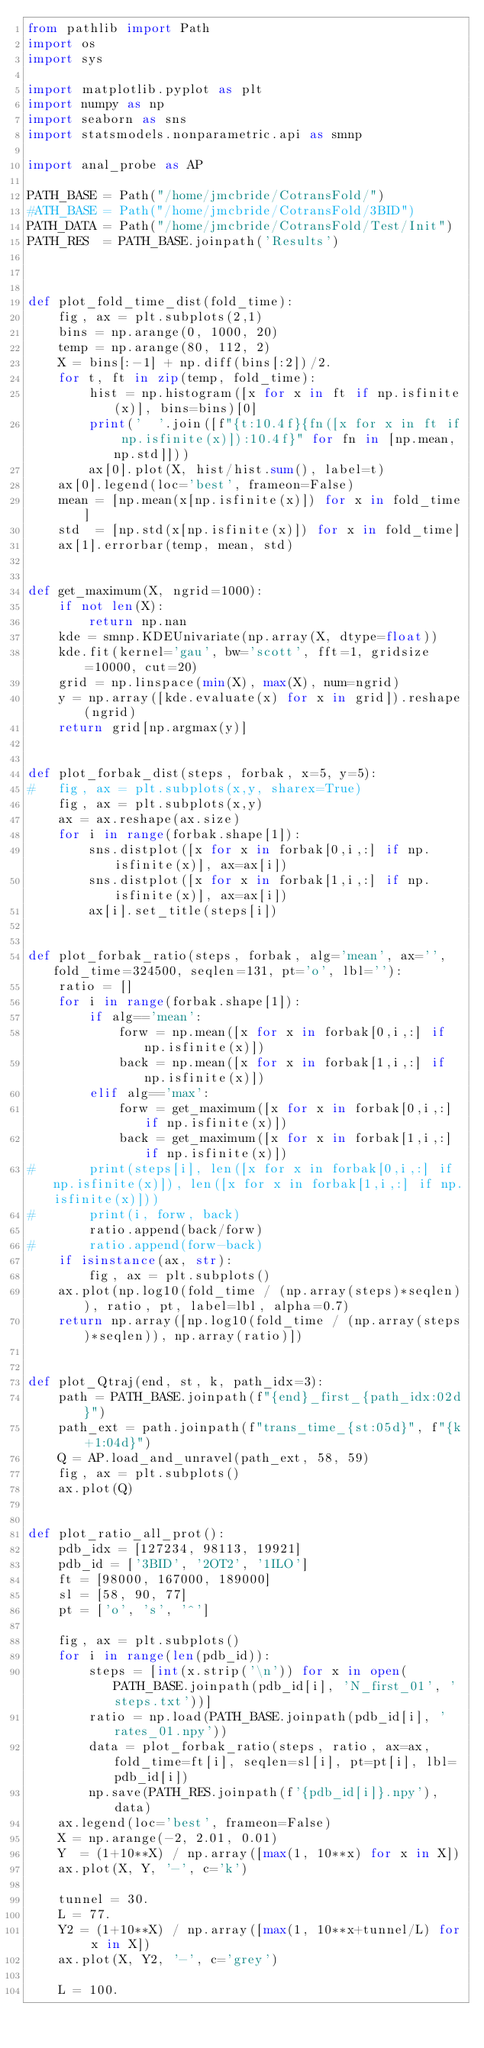Convert code to text. <code><loc_0><loc_0><loc_500><loc_500><_Python_>from pathlib import Path
import os
import sys

import matplotlib.pyplot as plt
import numpy as np
import seaborn as sns
import statsmodels.nonparametric.api as smnp 

import anal_probe as AP

PATH_BASE = Path("/home/jmcbride/CotransFold/")
#ATH_BASE = Path("/home/jmcbride/CotransFold/3BID")
PATH_DATA = Path("/home/jmcbride/CotransFold/Test/Init")
PATH_RES  = PATH_BASE.joinpath('Results')



def plot_fold_time_dist(fold_time):
    fig, ax = plt.subplots(2,1)
    bins = np.arange(0, 1000, 20)
    temp = np.arange(80, 112, 2)
    X = bins[:-1] + np.diff(bins[:2])/2.
    for t, ft in zip(temp, fold_time):
        hist = np.histogram([x for x in ft if np.isfinite(x)], bins=bins)[0]
        print('  '.join([f"{t:10.4f}{fn([x for x in ft if np.isfinite(x)]):10.4f}" for fn in [np.mean, np.std]]))
        ax[0].plot(X, hist/hist.sum(), label=t)
    ax[0].legend(loc='best', frameon=False)
    mean = [np.mean(x[np.isfinite(x)]) for x in fold_time]
    std  = [np.std(x[np.isfinite(x)]) for x in fold_time]
    ax[1].errorbar(temp, mean, std)


def get_maximum(X, ngrid=1000):
    if not len(X):
        return np.nan
    kde = smnp.KDEUnivariate(np.array(X, dtype=float))
    kde.fit(kernel='gau', bw='scott', fft=1, gridsize=10000, cut=20)
    grid = np.linspace(min(X), max(X), num=ngrid)
    y = np.array([kde.evaluate(x) for x in grid]).reshape(ngrid)
    return grid[np.argmax(y)]


def plot_forbak_dist(steps, forbak, x=5, y=5):
#   fig, ax = plt.subplots(x,y, sharex=True)
    fig, ax = plt.subplots(x,y)
    ax = ax.reshape(ax.size)
    for i in range(forbak.shape[1]):
        sns.distplot([x for x in forbak[0,i,:] if np.isfinite(x)], ax=ax[i])
        sns.distplot([x for x in forbak[1,i,:] if np.isfinite(x)], ax=ax[i])
        ax[i].set_title(steps[i])


def plot_forbak_ratio(steps, forbak, alg='mean', ax='', fold_time=324500, seqlen=131, pt='o', lbl=''):
    ratio = []
    for i in range(forbak.shape[1]):
        if alg=='mean':
            forw = np.mean([x for x in forbak[0,i,:] if np.isfinite(x)])
            back = np.mean([x for x in forbak[1,i,:] if np.isfinite(x)])
        elif alg=='max':
            forw = get_maximum([x for x in forbak[0,i,:] if np.isfinite(x)])
            back = get_maximum([x for x in forbak[1,i,:] if np.isfinite(x)])
#       print(steps[i], len([x for x in forbak[0,i,:] if np.isfinite(x)]), len([x for x in forbak[1,i,:] if np.isfinite(x)]))
#       print(i, forw, back)
        ratio.append(back/forw) 
#       ratio.append(forw-back) 
    if isinstance(ax, str):
        fig, ax = plt.subplots()
    ax.plot(np.log10(fold_time / (np.array(steps)*seqlen)), ratio, pt, label=lbl, alpha=0.7)
    return np.array([np.log10(fold_time / (np.array(steps)*seqlen)), np.array(ratio)])


def plot_Qtraj(end, st, k, path_idx=3):
    path = PATH_BASE.joinpath(f"{end}_first_{path_idx:02d}")
    path_ext = path.joinpath(f"trans_time_{st:05d}", f"{k+1:04d}")
    Q = AP.load_and_unravel(path_ext, 58, 59)
    fig, ax = plt.subplots()
    ax.plot(Q)


def plot_ratio_all_prot():
    pdb_idx = [127234, 98113, 19921]
    pdb_id = ['3BID', '2OT2', '1ILO']
    ft = [98000, 167000, 189000]
    sl = [58, 90, 77]
    pt = ['o', 's', '^']

    fig, ax = plt.subplots()
    for i in range(len(pdb_id)):
        steps = [int(x.strip('\n')) for x in open(PATH_BASE.joinpath(pdb_id[i], 'N_first_01', 'steps.txt'))]
        ratio = np.load(PATH_BASE.joinpath(pdb_id[i], 'rates_01.npy'))
        data = plot_forbak_ratio(steps, ratio, ax=ax, fold_time=ft[i], seqlen=sl[i], pt=pt[i], lbl=pdb_id[i])
        np.save(PATH_RES.joinpath(f'{pdb_id[i]}.npy'), data)
    ax.legend(loc='best', frameon=False)
    X = np.arange(-2, 2.01, 0.01)
    Y  = (1+10**X) / np.array([max(1, 10**x) for x in X])
    ax.plot(X, Y, '-', c='k')

    tunnel = 30.
    L = 77.
    Y2 = (1+10**X) / np.array([max(1, 10**x+tunnel/L) for x in X])
    ax.plot(X, Y2, '-', c='grey')

    L = 100.</code> 